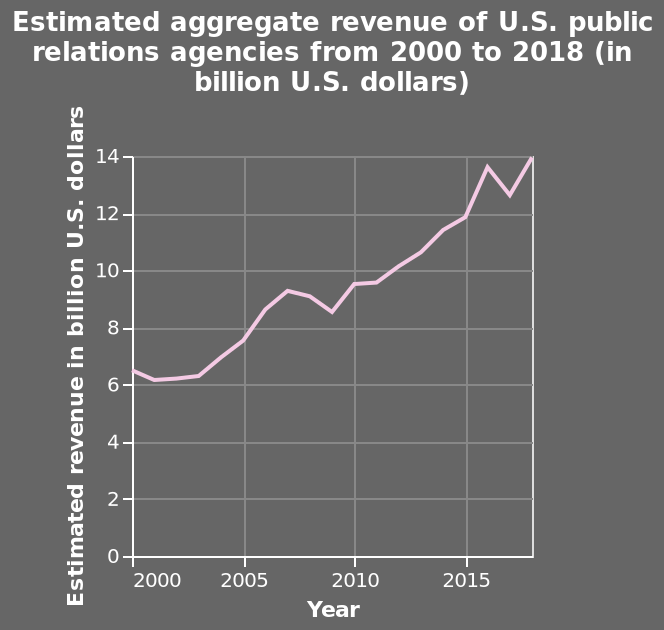<image>
Did the revenue increase or decrease after the dip in 2015? After the dip in 2015, the revenue had another jump. In what unit is the estimated revenue measured? The estimated revenue is measured in billion U.S. dollars. 